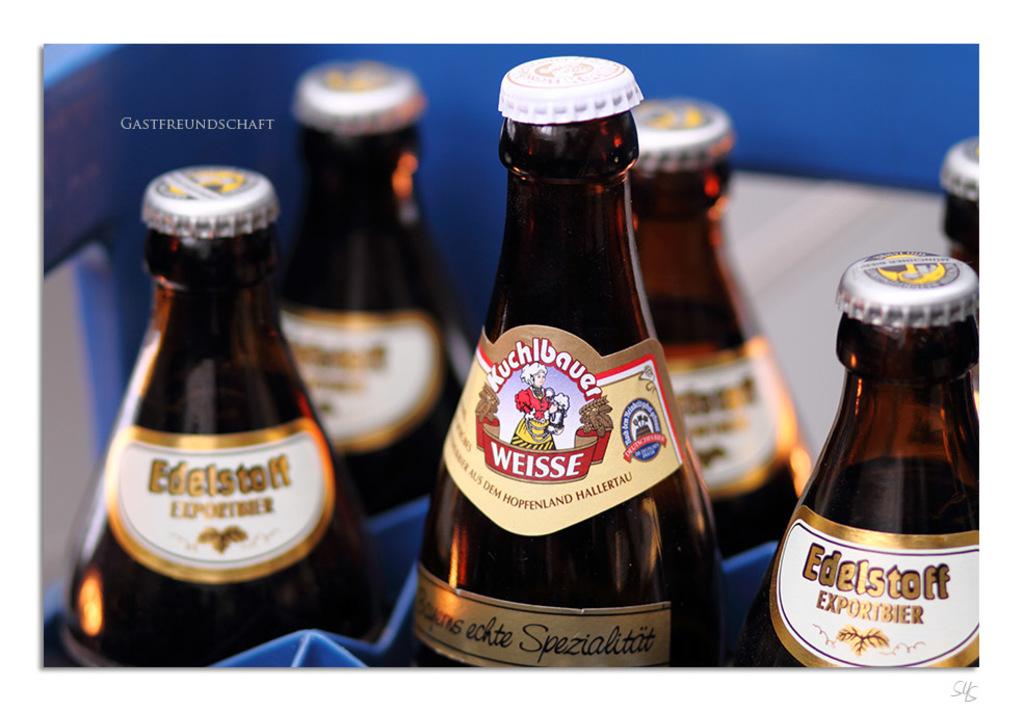What is the name of the drink in the middle?
Make the answer very short. Weisse. Are these all beer?
Offer a terse response. Answering does not require reading text in the image. 